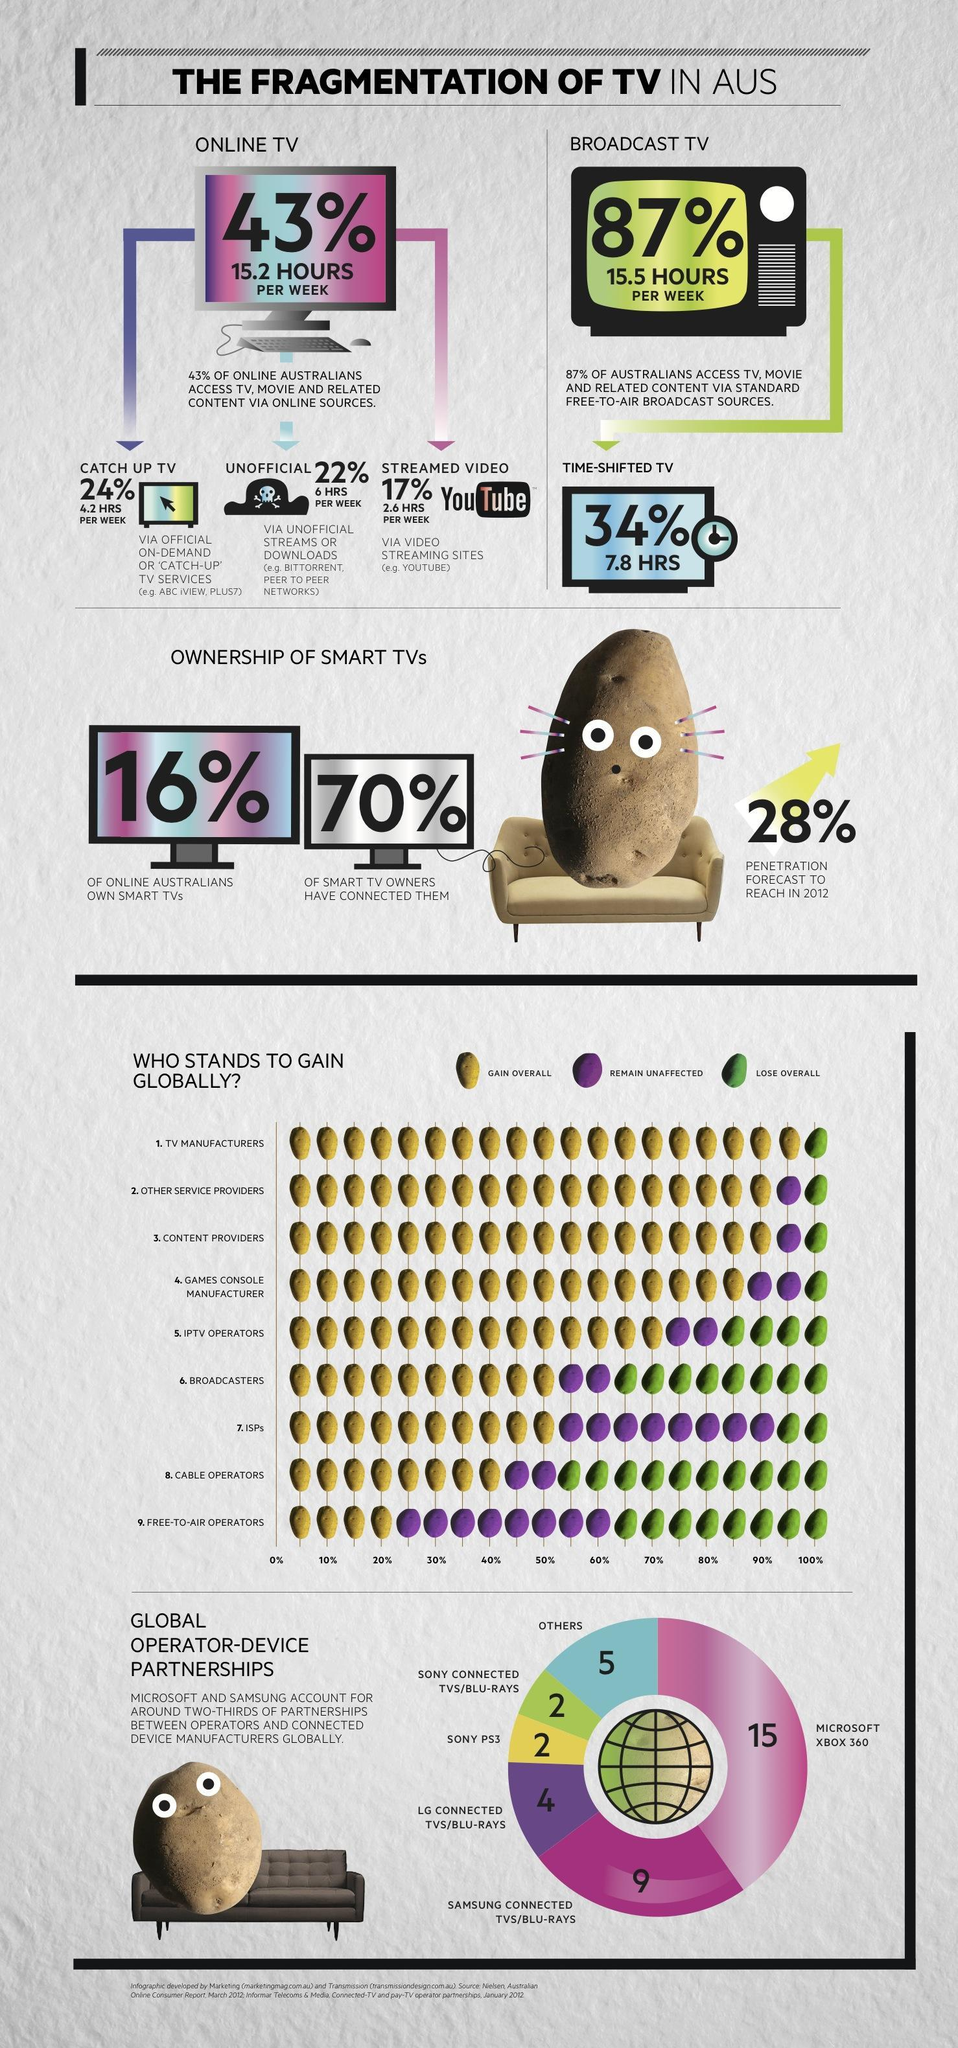What is the percentage of lose overall for broadcasters?
Answer the question with a short phrase. 40% Who gains the most overall? TV manufacturers Who gains the least overall? free-to-air operators Who loses the most overall? cable operators Which are the sectors who gains 50% overall? broadcasters, isps What is the percentage of overall gain for games console manufacturer? 85% Which are the sectors who gains 90% overall? other service providers, content providers Which has more access hours per week - online TV or broadcast TV? broadcast TV Who gains the third highest overall ? games console manufacturer What is the percentage of overall gain for TV manufacturers? 95% who lose only 10% overall? ISPs 